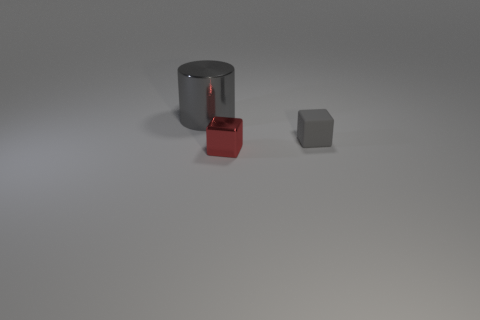There is a cube that is in front of the gray thing that is in front of the metallic object that is behind the red object; what is it made of?
Your answer should be compact. Metal. There is a shiny object that is behind the small red metallic block; is its color the same as the object on the right side of the red metal block?
Your answer should be compact. Yes. There is a cube behind the metal object that is in front of the cylinder; what is its material?
Your response must be concise. Rubber. What is the color of the other object that is the same size as the red metallic object?
Give a very brief answer. Gray. There is a red shiny object; is it the same shape as the gray thing that is to the right of the gray cylinder?
Offer a very short reply. Yes. There is a tiny matte object that is the same color as the shiny cylinder; what shape is it?
Ensure brevity in your answer.  Cube. There is a object in front of the gray object that is in front of the large gray cylinder; what number of gray matte things are left of it?
Provide a short and direct response. 0. There is a shiny thing that is to the right of the metallic thing that is behind the tiny gray rubber cube; what is its size?
Offer a very short reply. Small. There is a gray thing that is the same material as the red block; what size is it?
Your response must be concise. Large. There is a object that is behind the red metallic block and to the left of the small gray rubber object; what shape is it?
Your answer should be very brief. Cylinder. 